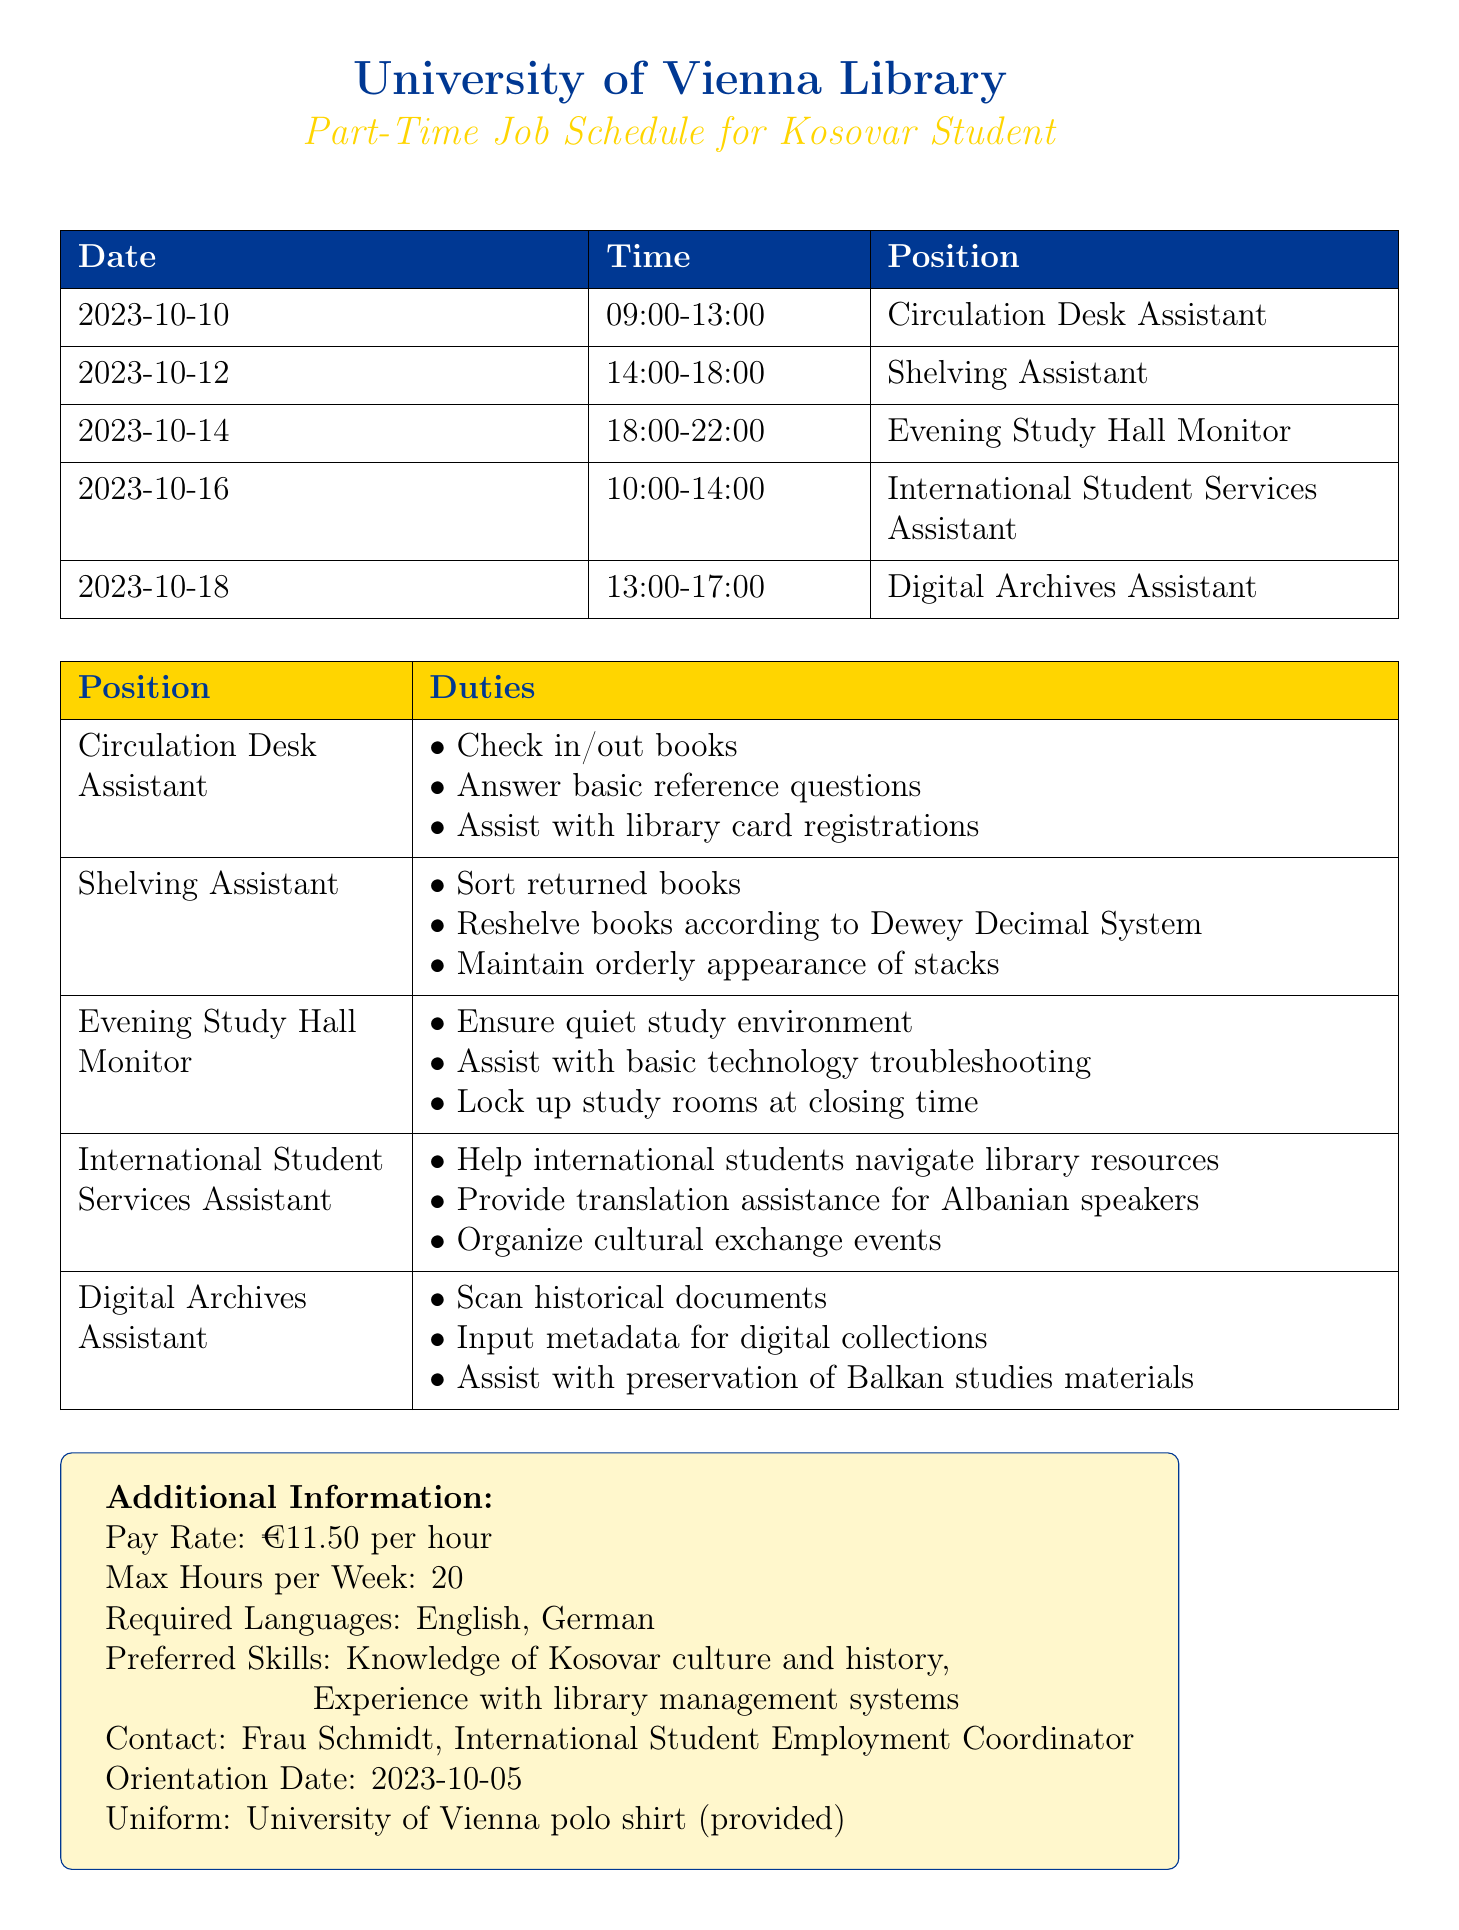what is the pay rate for the part-time job? The pay rate is mentioned in the additional information section of the document as €11.50 per hour.
Answer: €11.50 per hour who is the contact person for this job? The document specifies that the contact person is Frau Schmidt, the International Student Employment Coordinator.
Answer: Frau Schmidt what position is available on October 12? The document lists the available shifts, and on October 12, the position is Shelving Assistant.
Answer: Shelving Assistant how many max hours can be worked per week? The document states that the maximum hours per week for the part-time job is 20.
Answer: 20 what duty is associated with the Evening Study Hall Monitor position? The document outlines the duties for each position, and one duty for the Evening Study Hall Monitor is to ensure a quiet study environment.
Answer: Ensure quiet study environment which language is preferred for the part-time job? The preferred languages for the position are listed in the additional information section, which includes English and German.
Answer: English, German when is the orientation date? The orientation date is specified in the additional information section of the document as October 5, 2023.
Answer: 2023-10-05 what is the main duty of the Circulation Desk Assistant? The primary duty involves checking in and out books as noted in the duties for the Circulation Desk Assistant.
Answer: Check in/out books what time does the Digital Archives Assistant start work? According to the schedule, the Digital Archives Assistant begins work at 13:00 on October 18.
Answer: 13:00 